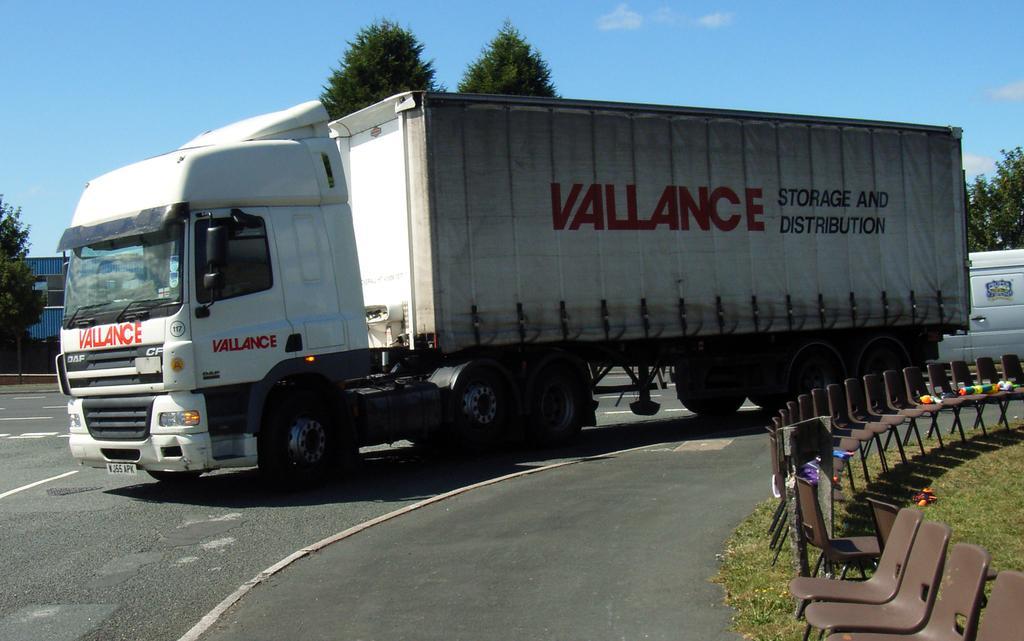How would you summarize this image in a sentence or two? In this picture we can see a vehicle or a truck on a road and aside to this we have chairs on grass with some toys on it and in background we can see sky, trees. 